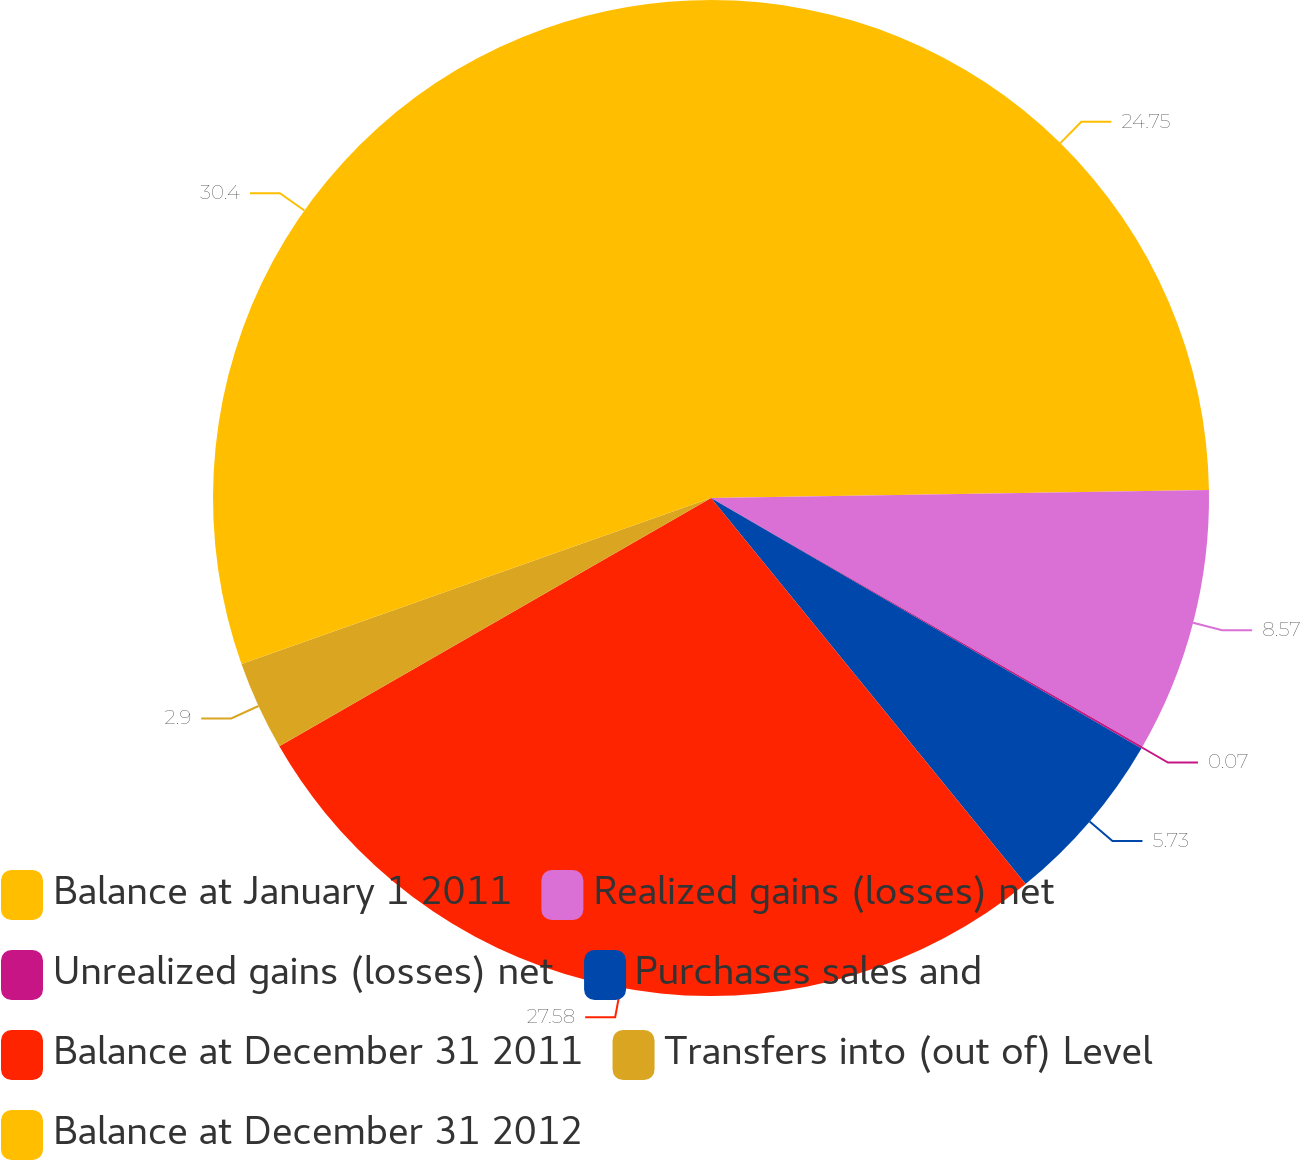Convert chart. <chart><loc_0><loc_0><loc_500><loc_500><pie_chart><fcel>Balance at January 1 2011<fcel>Realized gains (losses) net<fcel>Unrealized gains (losses) net<fcel>Purchases sales and<fcel>Balance at December 31 2011<fcel>Transfers into (out of) Level<fcel>Balance at December 31 2012<nl><fcel>24.75%<fcel>8.57%<fcel>0.07%<fcel>5.73%<fcel>27.58%<fcel>2.9%<fcel>30.41%<nl></chart> 